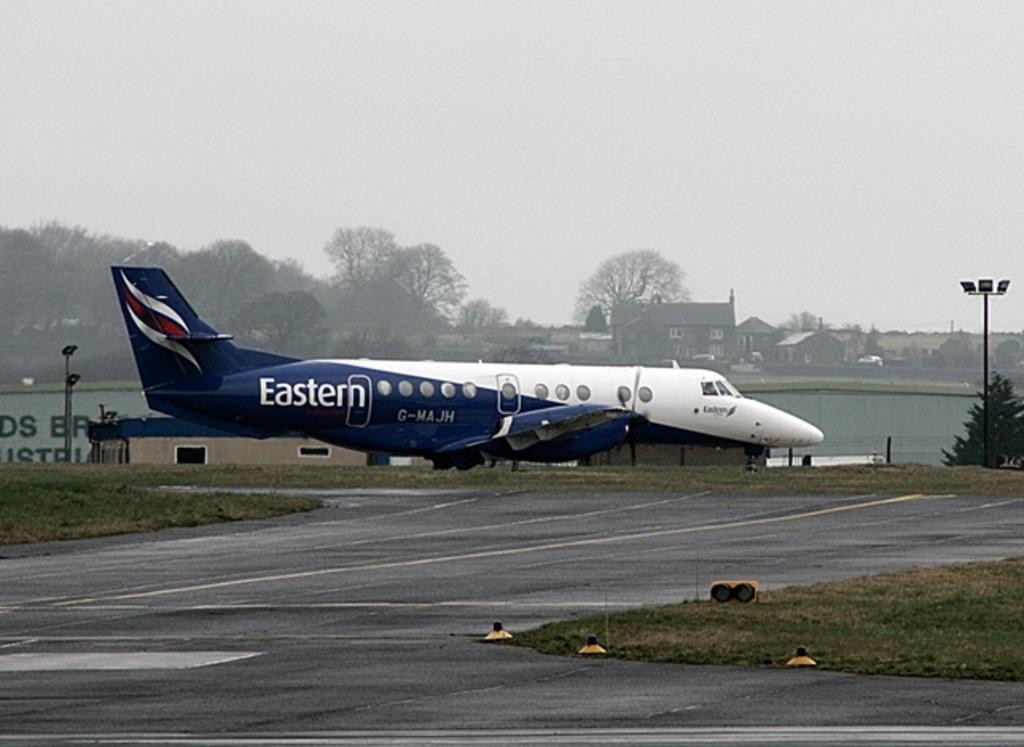What brand of airliner is this?
Your answer should be very brief. Eastern. What is the plane id?
Offer a terse response. G-majh. 